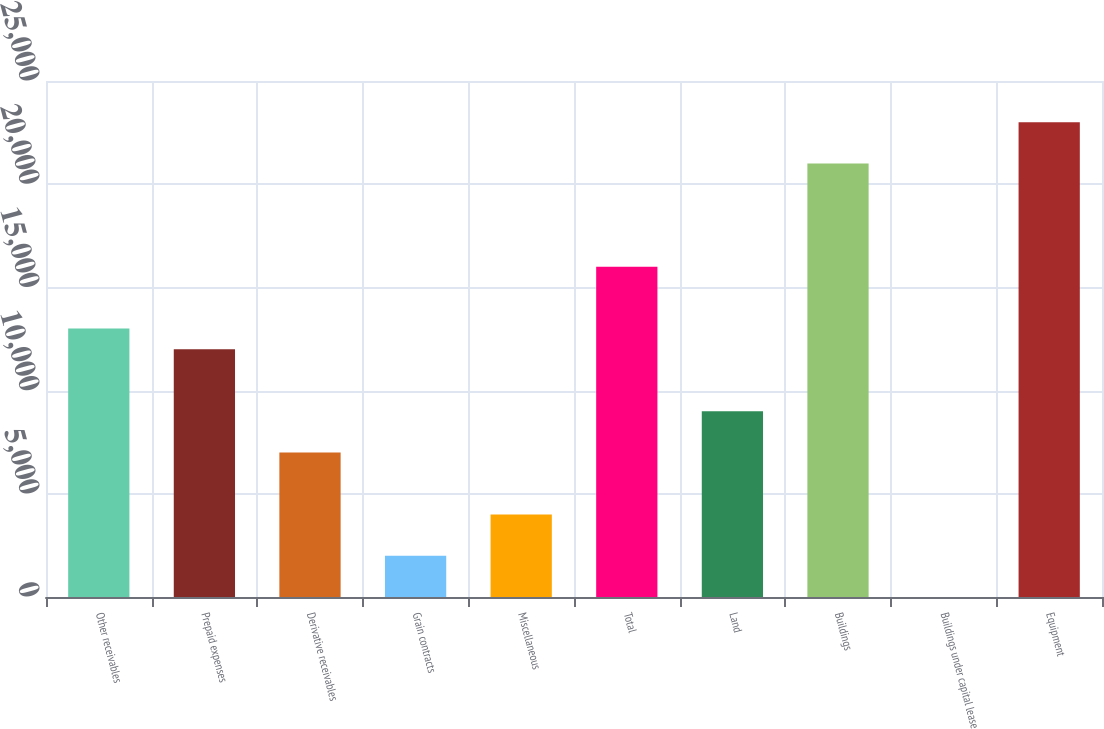Convert chart to OTSL. <chart><loc_0><loc_0><loc_500><loc_500><bar_chart><fcel>Other receivables<fcel>Prepaid expenses<fcel>Derivative receivables<fcel>Grain contracts<fcel>Miscellaneous<fcel>Total<fcel>Land<fcel>Buildings<fcel>Buildings under capital lease<fcel>Equipment<nl><fcel>13004.1<fcel>12003.8<fcel>7002.33<fcel>2000.88<fcel>4001.46<fcel>16004.9<fcel>9002.91<fcel>21006.4<fcel>0.3<fcel>23007<nl></chart> 